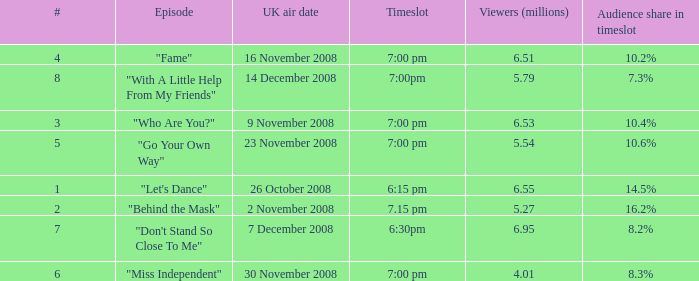Name the timeslot for 6.51 viewers 7:00 pm. 